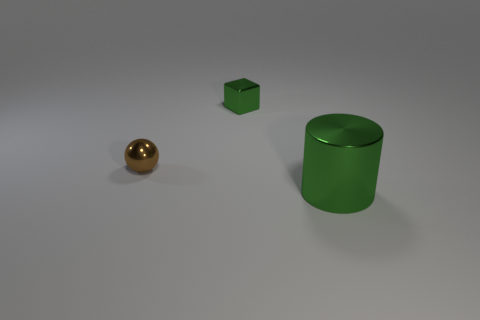Do the metal cylinder and the cube have the same color?
Ensure brevity in your answer.  Yes. There is a metal thing that is the same color as the small block; what size is it?
Provide a succinct answer. Large. How many yellow things are small shiny objects or metallic cubes?
Ensure brevity in your answer.  0. What number of other objects are there of the same shape as the tiny brown metallic thing?
Offer a very short reply. 0. The object that is behind the green metallic cylinder and in front of the small green metal cube has what shape?
Offer a very short reply. Sphere. There is a sphere; are there any brown objects in front of it?
Keep it short and to the point. No. Are there any other things that have the same size as the green cylinder?
Ensure brevity in your answer.  No. There is a green object that is left of the green metallic object that is in front of the small brown metal object; what is its size?
Ensure brevity in your answer.  Small. How many other balls are the same color as the sphere?
Keep it short and to the point. 0. How big is the green metal cylinder?
Offer a very short reply. Large. 